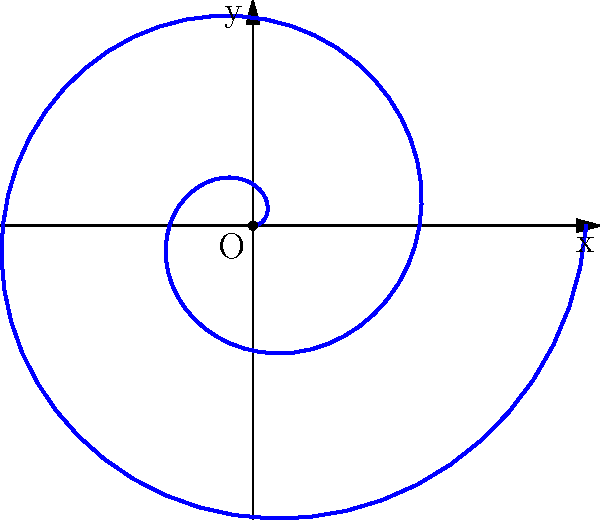In the traditional karate kata "Spiral of the Dragon," a practitioner moves in a spiral pattern starting from the center of the dojo. If the distance from the center increases proportionally to the angle of rotation, which polar equation best represents this movement pattern? To determine the polar equation that best represents the spiral movement pattern, let's analyze the given information step-by-step:

1) The practitioner starts from the center of the dojo, which corresponds to the origin $(0,0)$ in polar coordinates.

2) The distance from the center increases proportionally to the angle of rotation. This suggests a linear relationship between $r$ (radius) and $\theta$ (angle).

3) In polar coordinates, a linear spiral is represented by the equation $r = a\theta$, where $a$ is a constant that determines how tightly the spiral is wound.

4) The spiral in the image makes two complete rotations (4π radians) and reaches a maximum radius of about 2.5 units.

5) We can estimate the value of $a$ by dividing the maximum radius by the total angle:

   $a \approx \frac{2.5}{4\pi} \approx 0.2$

6) Therefore, the polar equation that best represents this movement pattern is $r = 0.2\theta$.

This equation ensures that the radius increases linearly with the angle, creating the spiral pattern shown in the diagram, which represents the kata movement sequence.
Answer: $r = 0.2\theta$ 